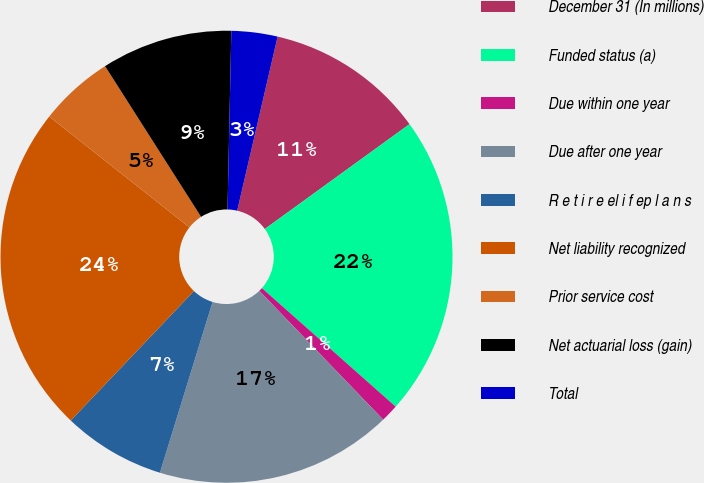<chart> <loc_0><loc_0><loc_500><loc_500><pie_chart><fcel>December 31 (In millions)<fcel>Funded status (a)<fcel>Due within one year<fcel>Due after one year<fcel>R e t i r e el i f ep l a n s<fcel>Net liability recognized<fcel>Prior service cost<fcel>Net actuarial loss (gain)<fcel>Total<nl><fcel>11.39%<fcel>21.52%<fcel>1.27%<fcel>16.95%<fcel>7.34%<fcel>23.55%<fcel>5.32%<fcel>9.37%<fcel>3.29%<nl></chart> 